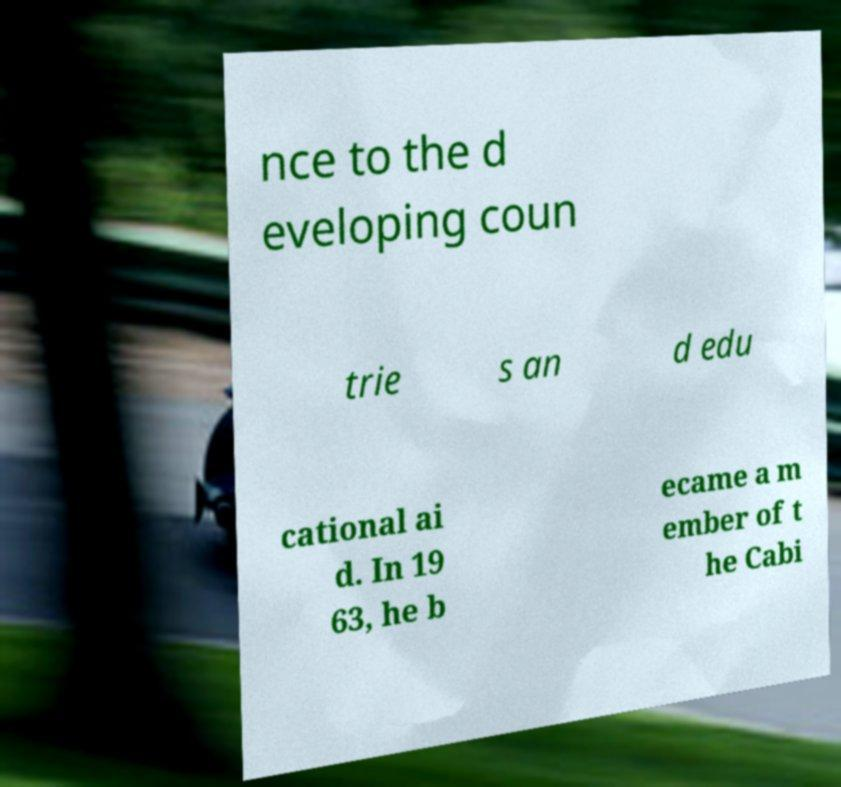For documentation purposes, I need the text within this image transcribed. Could you provide that? nce to the d eveloping coun trie s an d edu cational ai d. In 19 63, he b ecame a m ember of t he Cabi 